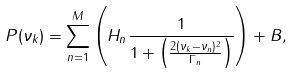Convert formula to latex. <formula><loc_0><loc_0><loc_500><loc_500>P ( \nu _ { k } ) = \sum _ { n = 1 } ^ { M } \left ( H _ { n } \frac { 1 } { 1 + \left ( \frac { 2 ( \nu _ { k } - \nu _ { n } ) ^ { 2 } } { \Gamma _ { n } } \right ) } \right ) + B ,</formula> 